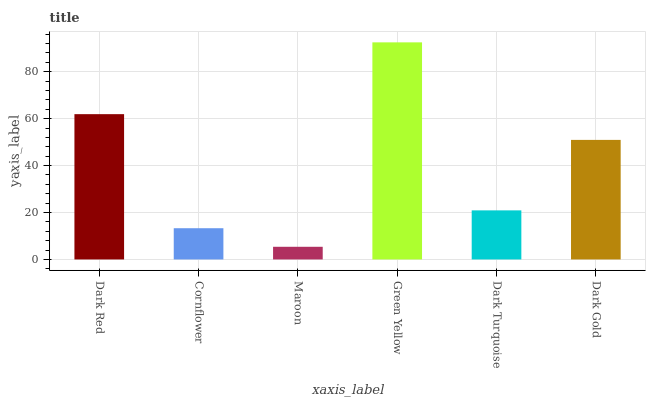Is Maroon the minimum?
Answer yes or no. Yes. Is Green Yellow the maximum?
Answer yes or no. Yes. Is Cornflower the minimum?
Answer yes or no. No. Is Cornflower the maximum?
Answer yes or no. No. Is Dark Red greater than Cornflower?
Answer yes or no. Yes. Is Cornflower less than Dark Red?
Answer yes or no. Yes. Is Cornflower greater than Dark Red?
Answer yes or no. No. Is Dark Red less than Cornflower?
Answer yes or no. No. Is Dark Gold the high median?
Answer yes or no. Yes. Is Dark Turquoise the low median?
Answer yes or no. Yes. Is Maroon the high median?
Answer yes or no. No. Is Dark Red the low median?
Answer yes or no. No. 